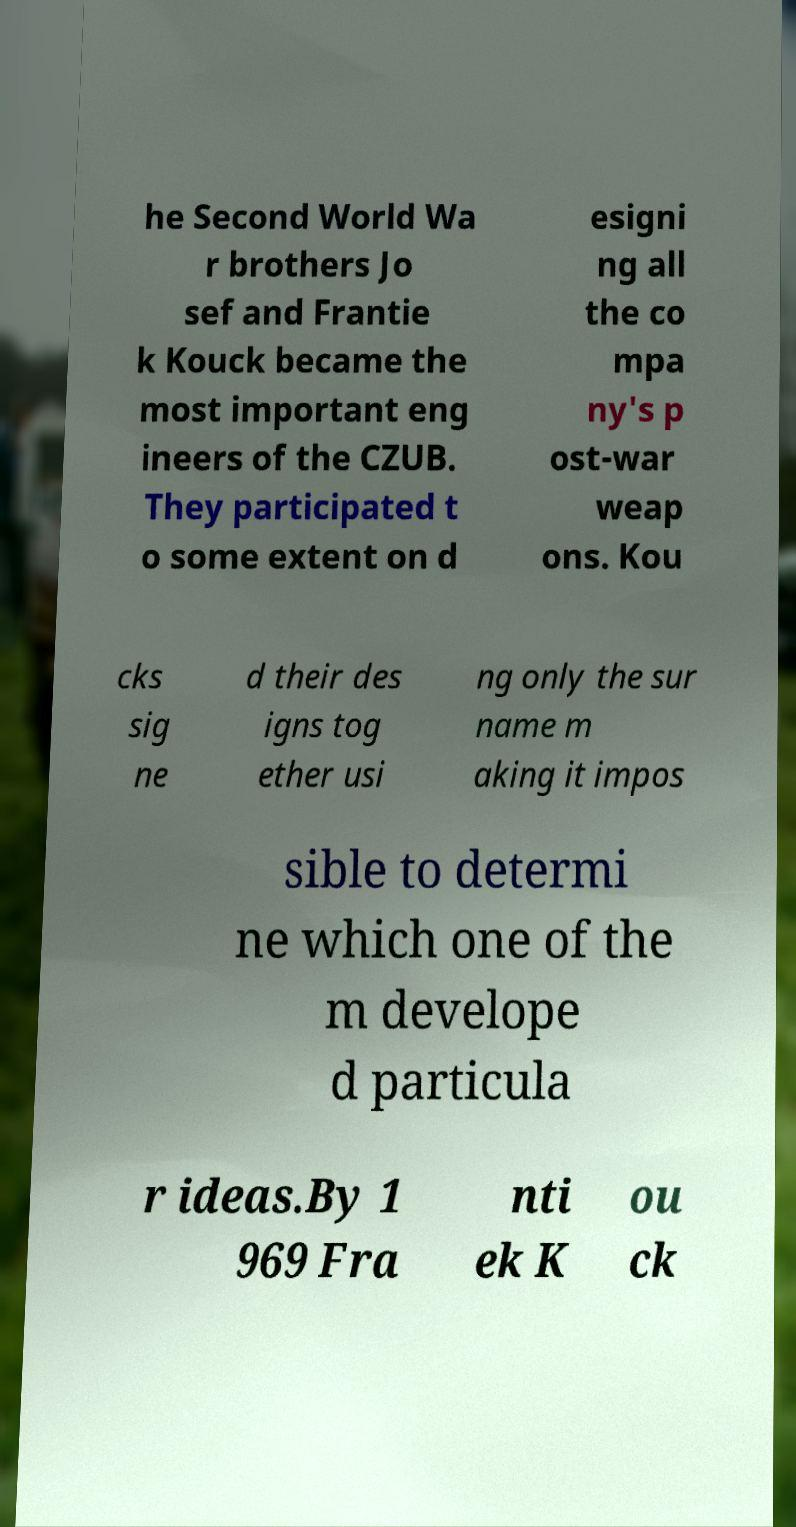What messages or text are displayed in this image? I need them in a readable, typed format. he Second World Wa r brothers Jo sef and Frantie k Kouck became the most important eng ineers of the CZUB. They participated t o some extent on d esigni ng all the co mpa ny's p ost-war weap ons. Kou cks sig ne d their des igns tog ether usi ng only the sur name m aking it impos sible to determi ne which one of the m develope d particula r ideas.By 1 969 Fra nti ek K ou ck 